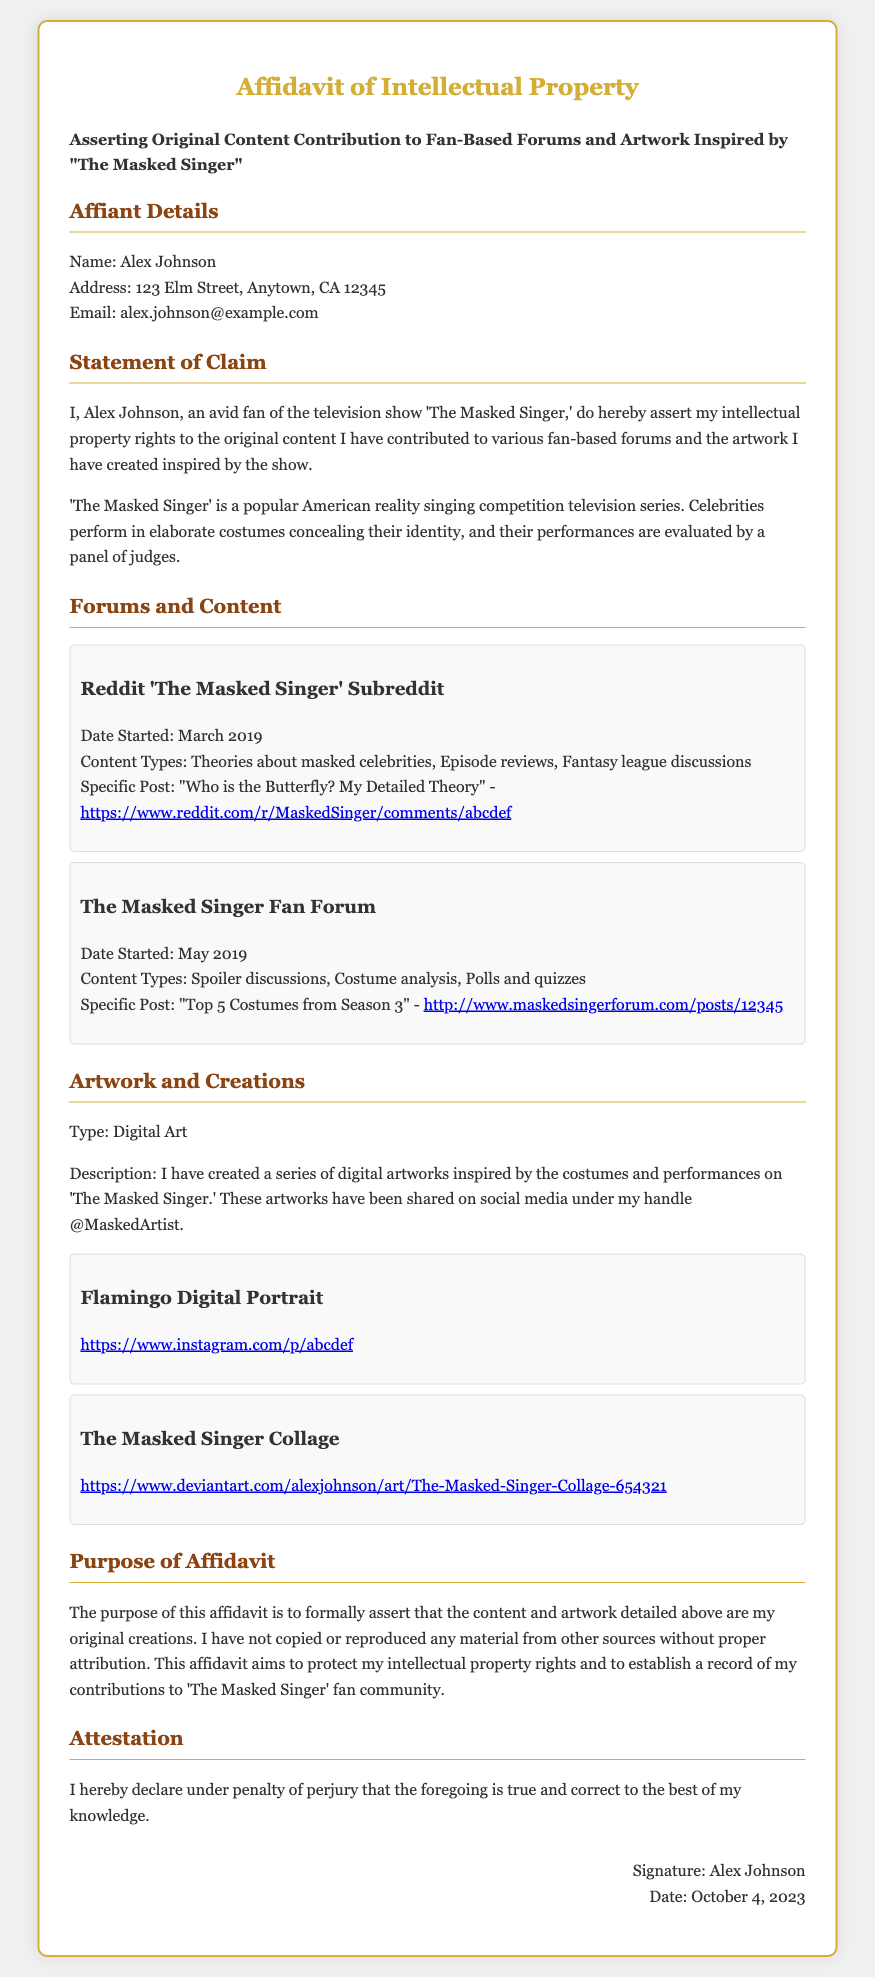What is the name of the affiant? The name of the affiant is stated in the document as Alex Johnson.
Answer: Alex Johnson What is the address of the affiant? The address provided in the document indicates the location of the affiant's residence.
Answer: 123 Elm Street, Anytown, CA 12345 What is the email address listed in the affidavit? The email address of the affiant is included to facilitate communication regarding the affidavit.
Answer: alex.johnson@example.com What type of content is claimed in the affidavit? The affidavit asserts rights over a specific category of contributions related to fan interactions.
Answer: Original content When did Alex Johnson start contributing to the Reddit 'The Masked Singer' subreddit? The date noted in the document marks the beginning of contributions to the subreddit.
Answer: March 2019 What is the specific post mentioned in the Reddit subreddit contribution? The document references a particular post made by the affiant in relation to their contributions.
Answer: "Who is the Butterfly? My Detailed Theory" What artwork type is detailed in the affidavit? The type of artwork created by the affiant is specified in the affidavit.
Answer: Digital Art What is the purpose of the affidavit stated in the document? The document outlines the main goal for submitting the affidavit concerning content and artwork.
Answer: To formally assert original creations What does the affiant declare under penalty of? The concluding statement in the affidavit mentions the consequences of false declarations.
Answer: Perjury 